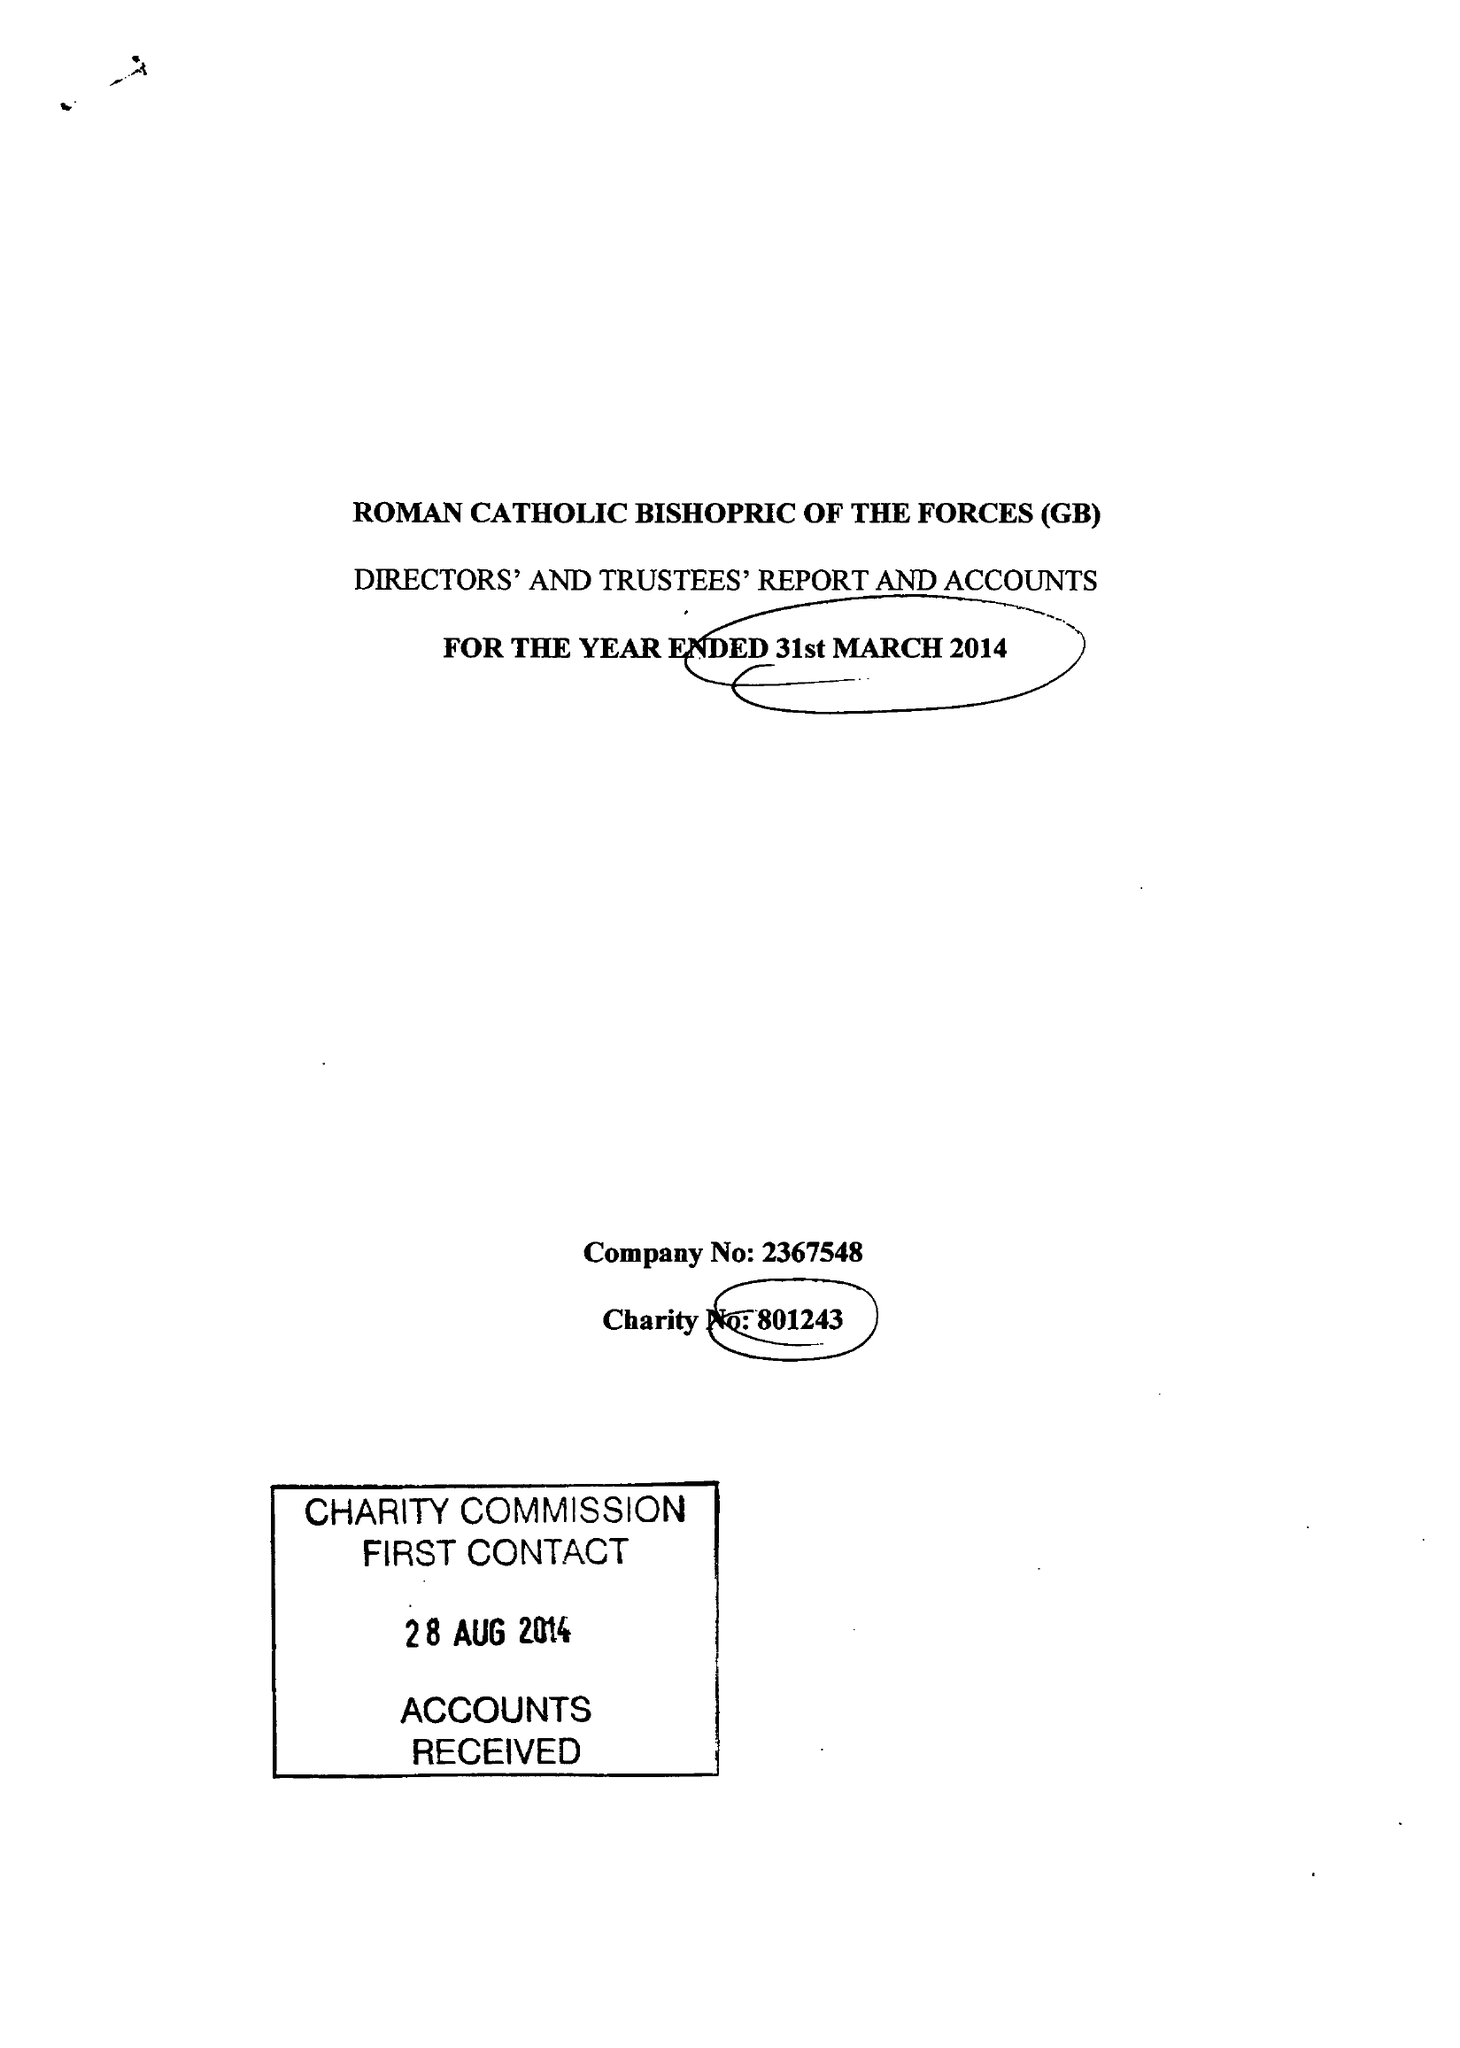What is the value for the charity_name?
Answer the question using a single word or phrase. The Roman Catholic Bishopric Of The Forces (Gb) 